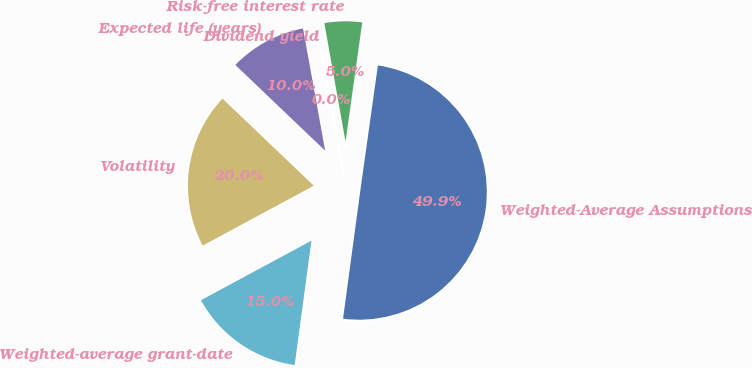<chart> <loc_0><loc_0><loc_500><loc_500><pie_chart><fcel>Weighted-Average Assumptions<fcel>Risk-free interest rate<fcel>Dividend yield<fcel>Expected life (years)<fcel>Volatility<fcel>Weighted-average grant-date<nl><fcel>49.91%<fcel>5.03%<fcel>0.04%<fcel>10.02%<fcel>19.99%<fcel>15.0%<nl></chart> 